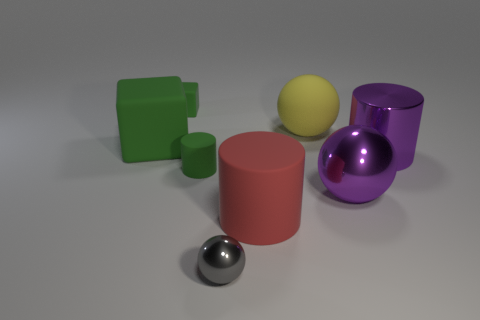Could you describe the shapes present in this image? Certainly, the image features a variety of geometric shapes: there's a cube, a small cylinder, a larger cylinder, a small sphere, and a larger sphere, all resting on a flat surface. Are the objects casting shadows? Yes, each object is casting a soft shadow on the surface beneath it, indicating a light source above and to the left of the scene. 